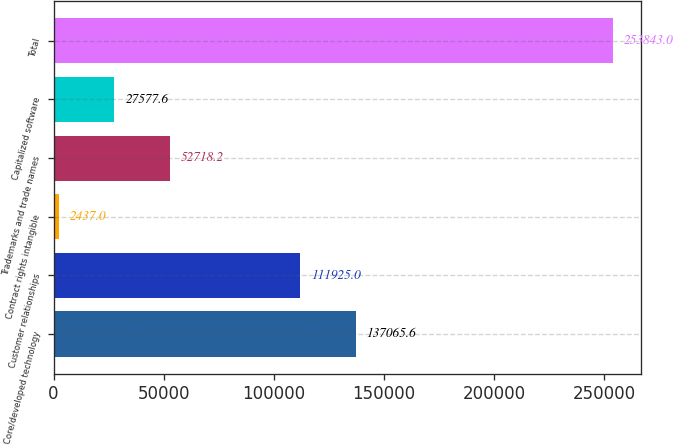Convert chart to OTSL. <chart><loc_0><loc_0><loc_500><loc_500><bar_chart><fcel>Core/developed technology<fcel>Customer relationships<fcel>Contract rights intangible<fcel>Trademarks and trade names<fcel>Capitalized software<fcel>Total<nl><fcel>137066<fcel>111925<fcel>2437<fcel>52718.2<fcel>27577.6<fcel>253843<nl></chart> 